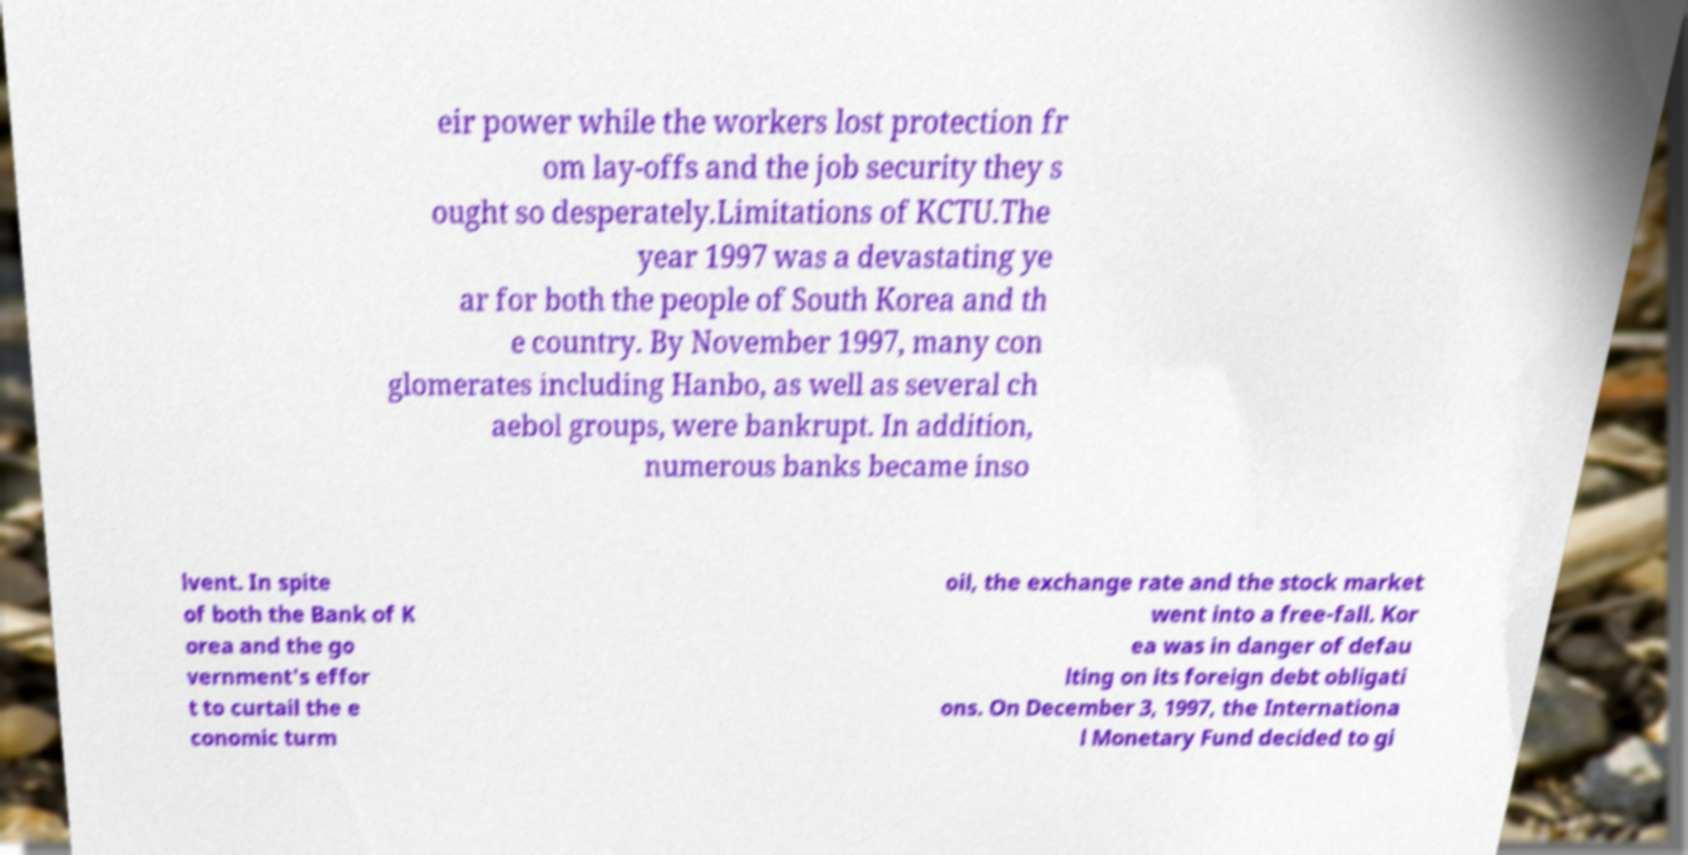What messages or text are displayed in this image? I need them in a readable, typed format. eir power while the workers lost protection fr om lay-offs and the job security they s ought so desperately.Limitations of KCTU.The year 1997 was a devastating ye ar for both the people of South Korea and th e country. By November 1997, many con glomerates including Hanbo, as well as several ch aebol groups, were bankrupt. In addition, numerous banks became inso lvent. In spite of both the Bank of K orea and the go vernment's effor t to curtail the e conomic turm oil, the exchange rate and the stock market went into a free-fall. Kor ea was in danger of defau lting on its foreign debt obligati ons. On December 3, 1997, the Internationa l Monetary Fund decided to gi 